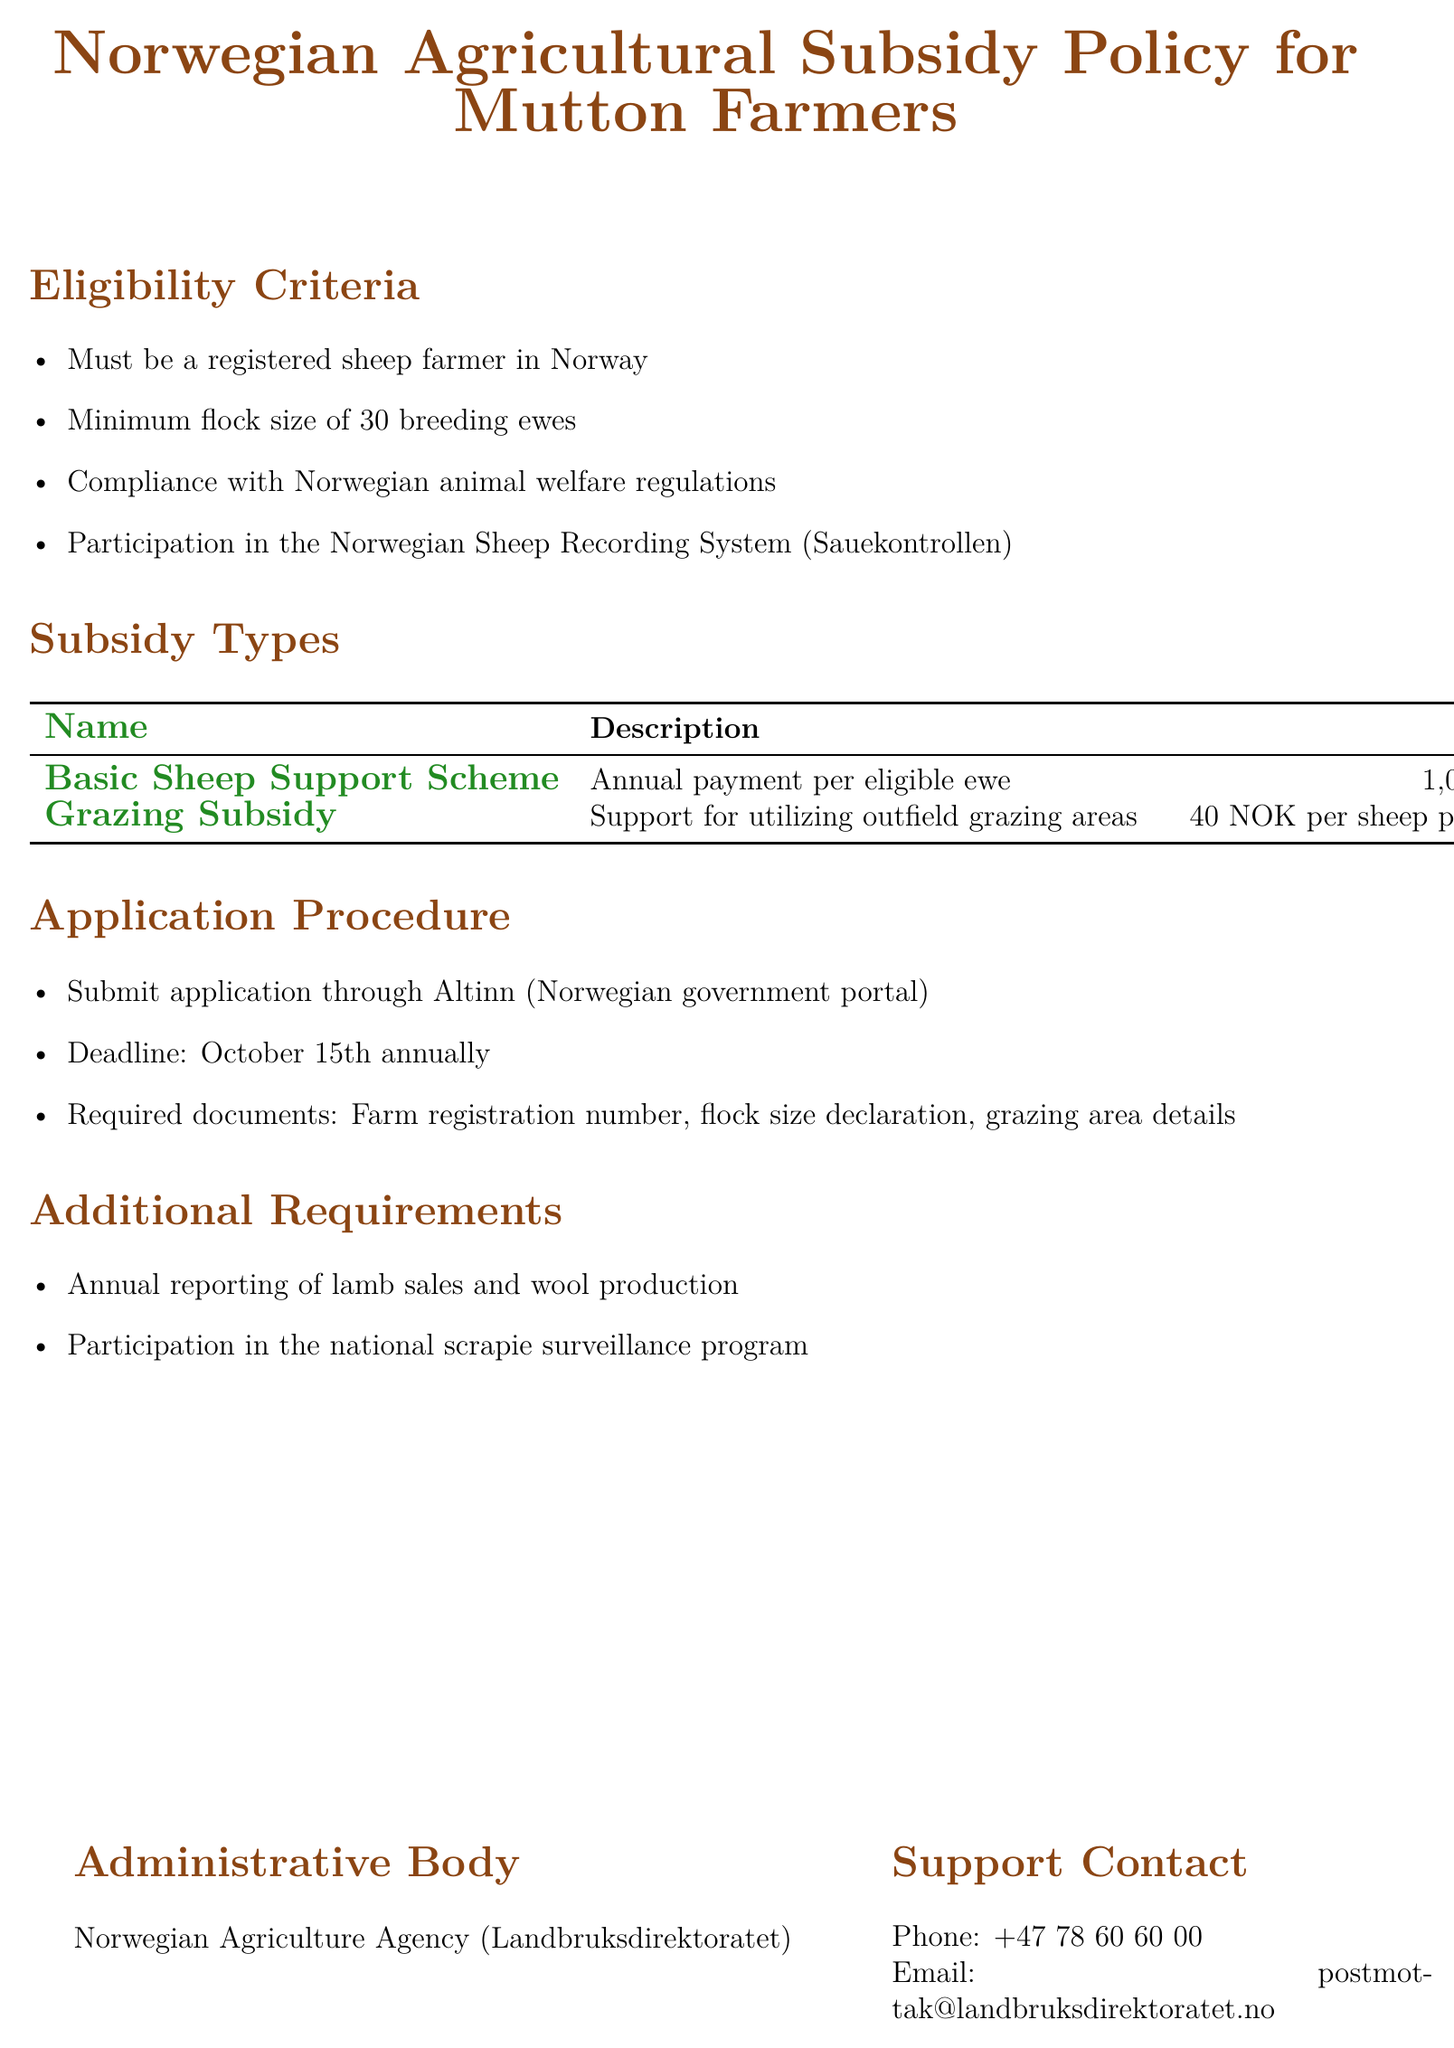What is the minimum flock size for eligibility? The document states that the minimum flock size is necessary for eligibility and specifies it as 30 breeding ewes.
Answer: 30 breeding ewes What is the annual payment per eligible ewe? In the section about subsidy types, the document indicates the amount for the Basic Sheep Support Scheme as 1,050 Norwegian Kroner per ewe.
Answer: 1,050 NOK per ewe What is the deadline for the application? The application procedure mentions that the deadline is set for October 15th annually.
Answer: October 15th Which body administers the subsidy policy? The document provides details about the administrative body responsible for the policy, which is the Norwegian Agriculture Agency.
Answer: Norwegian Agriculture Agency What is required to apply through Altinn? The application procedure mandates that applicants submit several documents, including farm registration number, flock size declaration, and grazing area details.
Answer: Farm registration number, flock size declaration, grazing area details What support is provided for utilizing outfield grazing areas? The document details the Grazing Subsidy, which is a financial support given specifically for outfield grazing.
Answer: Support for utilizing outfield grazing areas What program must farmers participate in regarding scrapie? The document outlines additional requirements that include participation in the national scrapie surveillance program.
Answer: National scrapie surveillance program 